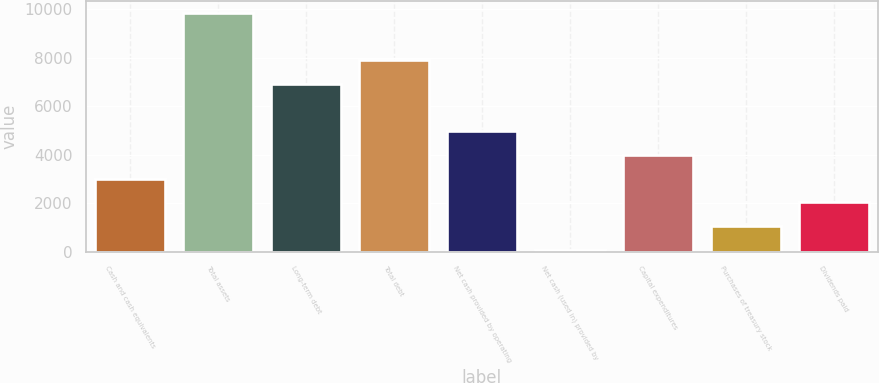Convert chart to OTSL. <chart><loc_0><loc_0><loc_500><loc_500><bar_chart><fcel>Cash and cash equivalents<fcel>Total assets<fcel>Long-term debt<fcel>Total debt<fcel>Net cash provided by operating<fcel>Net cash (used in) provided by<fcel>Capital expenditures<fcel>Purchases of treasury stock<fcel>Dividends paid<nl><fcel>3017.3<fcel>9857<fcel>6925.7<fcel>7902.8<fcel>4971.5<fcel>86<fcel>3994.4<fcel>1063.1<fcel>2040.2<nl></chart> 